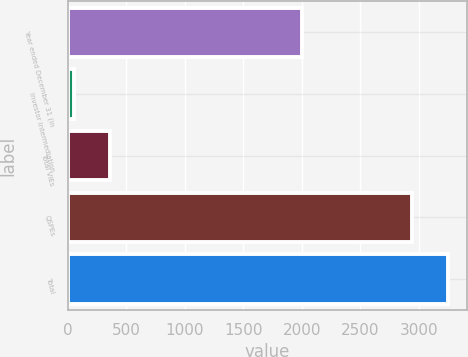Convert chart. <chart><loc_0><loc_0><loc_500><loc_500><bar_chart><fcel>Year ended December 31 (in<fcel>Investor intermediation<fcel>Total VIEs<fcel>QSPEs<fcel>Total<nl><fcel>2005<fcel>50<fcel>361.2<fcel>2940<fcel>3251.2<nl></chart> 